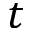<formula> <loc_0><loc_0><loc_500><loc_500>t</formula> 